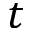<formula> <loc_0><loc_0><loc_500><loc_500>t</formula> 